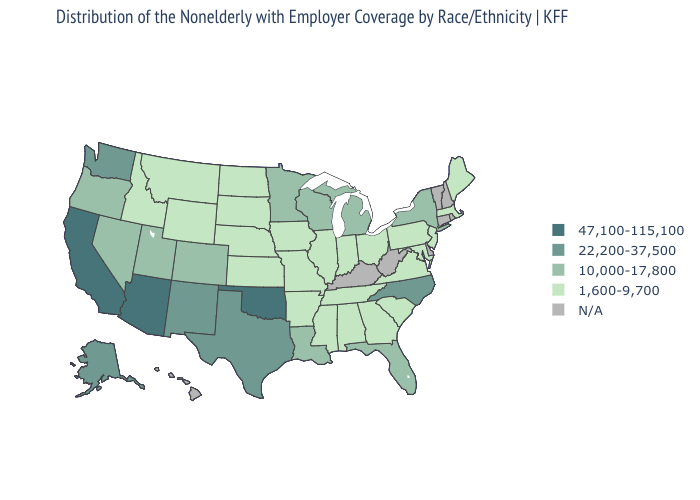Which states have the lowest value in the South?
Write a very short answer. Alabama, Arkansas, Georgia, Maryland, Mississippi, South Carolina, Tennessee, Virginia. What is the value of Wyoming?
Be succinct. 1,600-9,700. Which states have the lowest value in the Northeast?
Concise answer only. Maine, Massachusetts, New Jersey, Pennsylvania. Does Michigan have the highest value in the MidWest?
Keep it brief. Yes. Does the first symbol in the legend represent the smallest category?
Short answer required. No. Among the states that border Oklahoma , which have the highest value?
Be succinct. New Mexico, Texas. Which states have the lowest value in the MidWest?
Be succinct. Illinois, Indiana, Iowa, Kansas, Missouri, Nebraska, North Dakota, Ohio, South Dakota. Name the states that have a value in the range 1,600-9,700?
Concise answer only. Alabama, Arkansas, Georgia, Idaho, Illinois, Indiana, Iowa, Kansas, Maine, Maryland, Massachusetts, Mississippi, Missouri, Montana, Nebraska, New Jersey, North Dakota, Ohio, Pennsylvania, South Carolina, South Dakota, Tennessee, Virginia, Wyoming. Does California have the highest value in the USA?
Write a very short answer. Yes. What is the lowest value in the Northeast?
Short answer required. 1,600-9,700. How many symbols are there in the legend?
Answer briefly. 5. Does California have the lowest value in the USA?
Quick response, please. No. What is the value of Delaware?
Concise answer only. N/A. What is the value of West Virginia?
Answer briefly. N/A. 